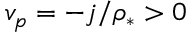Convert formula to latex. <formula><loc_0><loc_0><loc_500><loc_500>v _ { p } = - j / \rho _ { * } > 0</formula> 